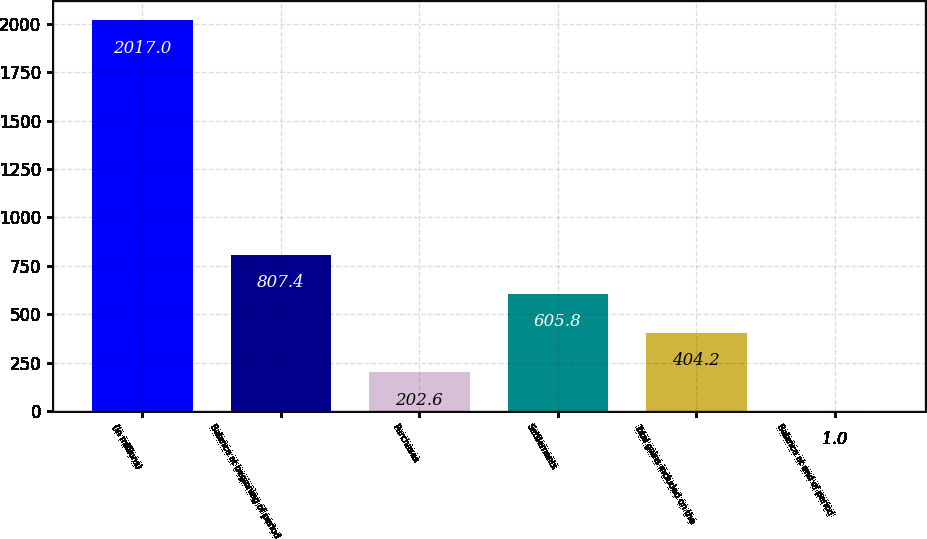<chart> <loc_0><loc_0><loc_500><loc_500><bar_chart><fcel>(in millions)<fcel>Balance at beginning of period<fcel>Purchases<fcel>Settlements<fcel>Total gains included on the<fcel>Balance at end of period<nl><fcel>2017<fcel>807.4<fcel>202.6<fcel>605.8<fcel>404.2<fcel>1<nl></chart> 